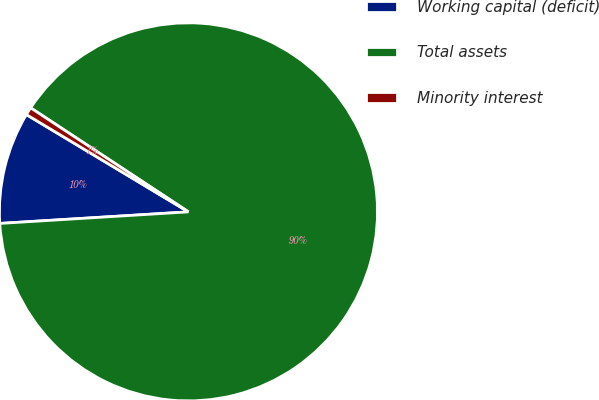<chart> <loc_0><loc_0><loc_500><loc_500><pie_chart><fcel>Working capital (deficit)<fcel>Total assets<fcel>Minority interest<nl><fcel>9.58%<fcel>89.75%<fcel>0.67%<nl></chart> 